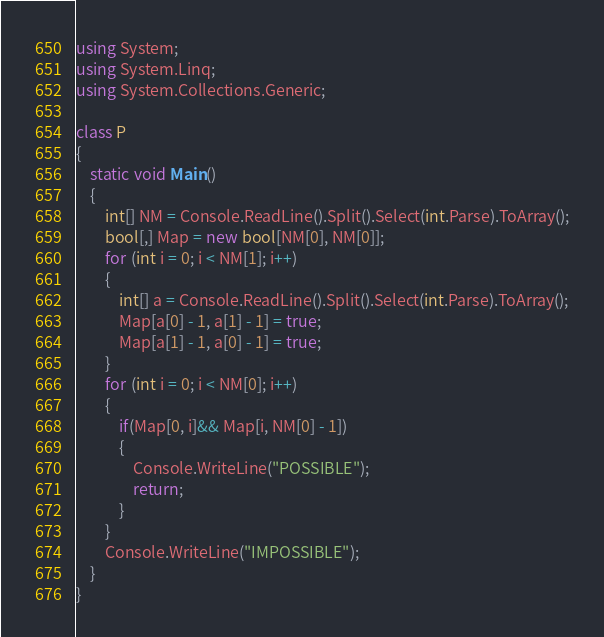Convert code to text. <code><loc_0><loc_0><loc_500><loc_500><_C#_>using System;
using System.Linq;
using System.Collections.Generic;

class P
{
    static void Main()
    {
        int[] NM = Console.ReadLine().Split().Select(int.Parse).ToArray();
        bool[,] Map = new bool[NM[0], NM[0]];
        for (int i = 0; i < NM[1]; i++)
        {
            int[] a = Console.ReadLine().Split().Select(int.Parse).ToArray();
            Map[a[0] - 1, a[1] - 1] = true;
            Map[a[1] - 1, a[0] - 1] = true;
        }
        for (int i = 0; i < NM[0]; i++)
        {
            if(Map[0, i]&& Map[i, NM[0] - 1])
            {
                Console.WriteLine("POSSIBLE");
                return;
            }
        }
        Console.WriteLine("IMPOSSIBLE");
    }
}</code> 